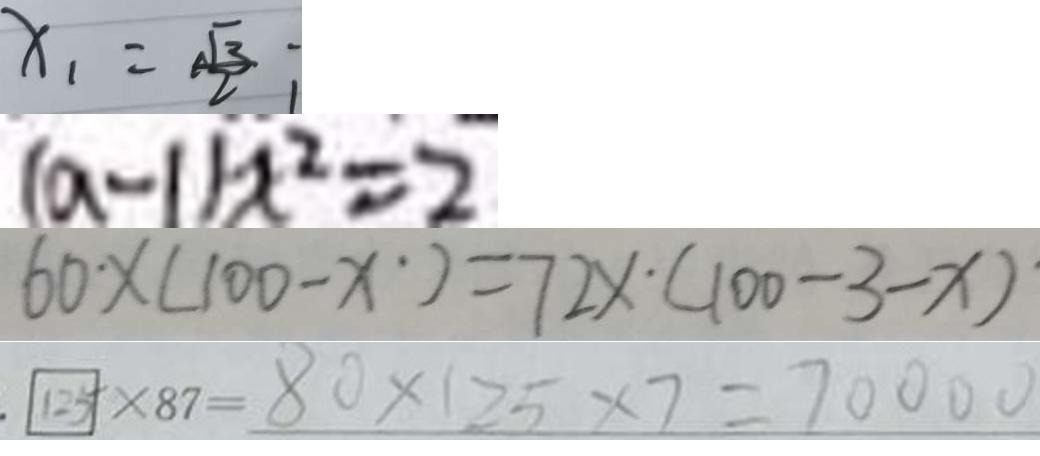<formula> <loc_0><loc_0><loc_500><loc_500>x _ { 1 } = \frac { \sqrt { 3 } } { 2 } 
 ( a - 1 ) x ^ { 2 } = 2 
 6 0 \times ( 1 0 0 - x ) = 7 2 x \cdot ( 1 0 0 - 3 - x ) 
 1 2 5 \times 8 7 = 8 0 \times 1 2 5 \times 7 = 7 0 0 0 0</formula> 